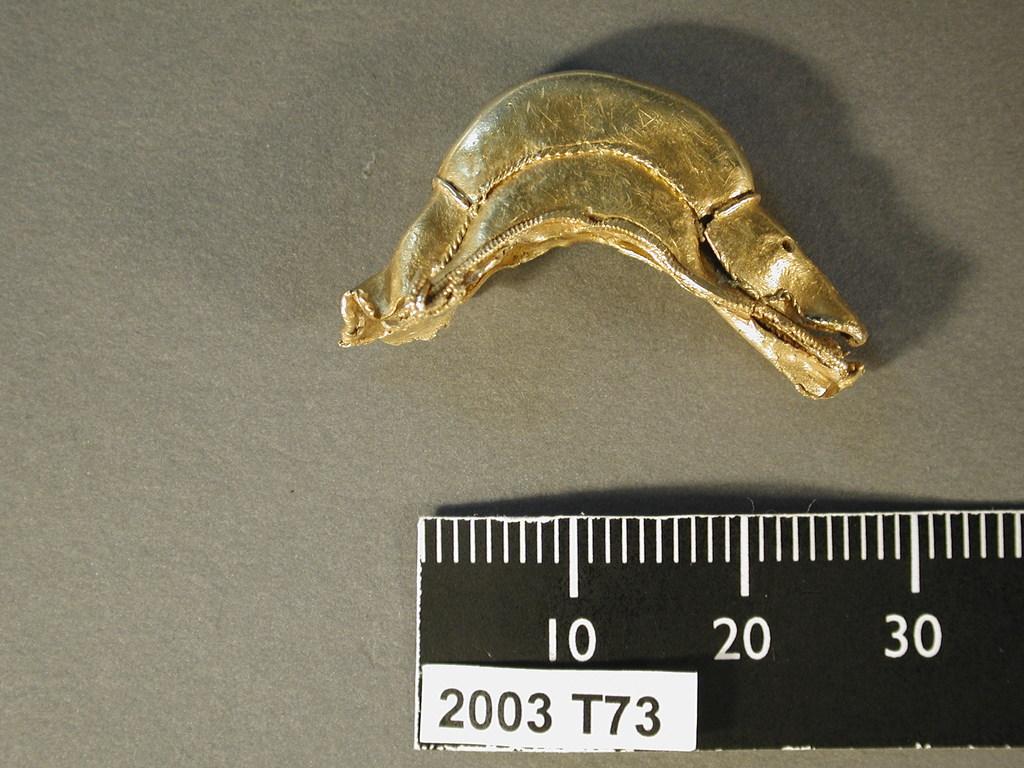What number does this piece of material measure to?
Ensure brevity in your answer.  30. What year is displayed on the ruler?
Your response must be concise. 2003. 